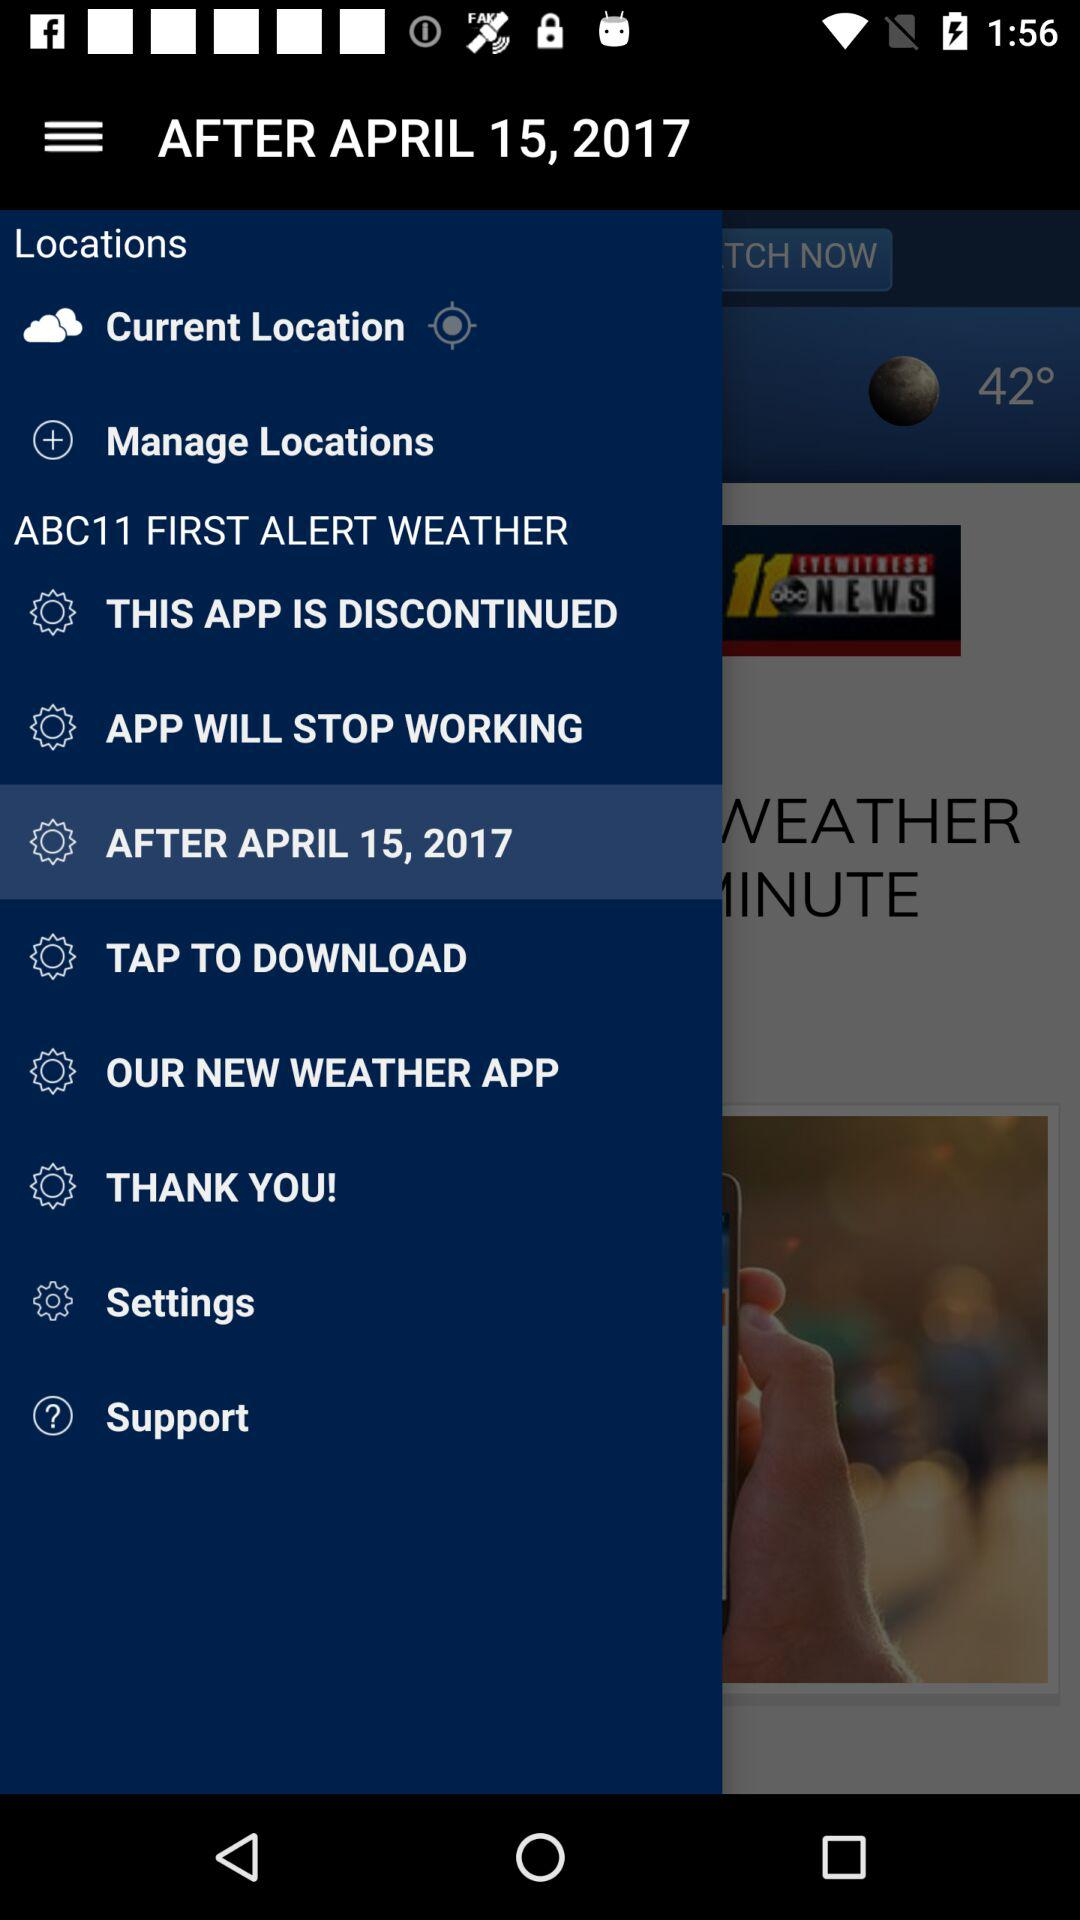Which item is selected in the menu? The selected item in the menu is "AFTER APRIL 15, 2017". 